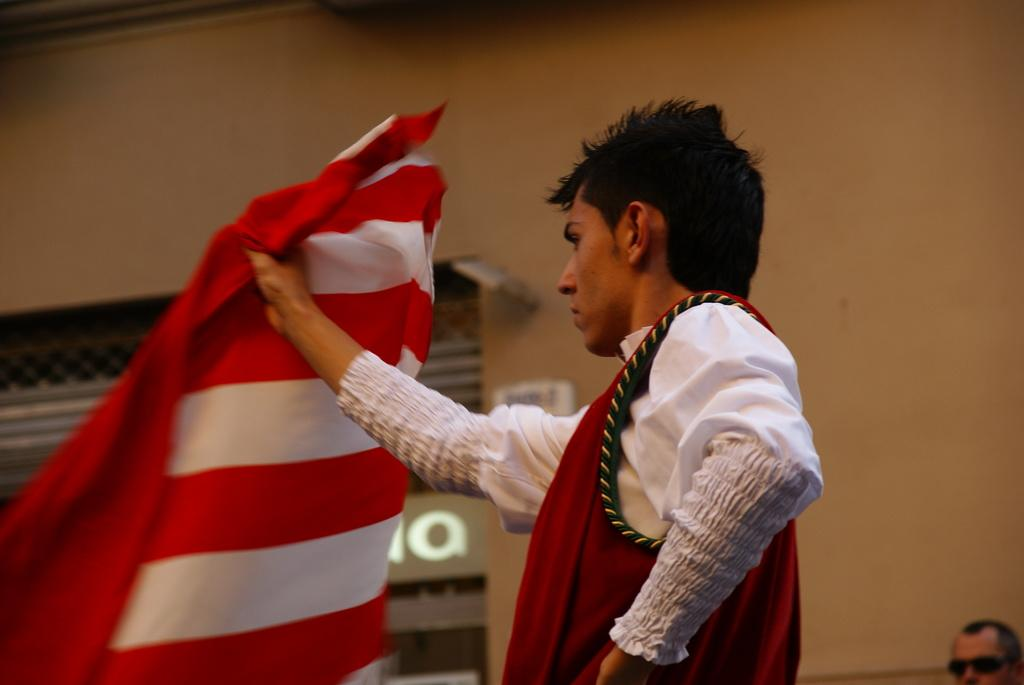How many people are in the image? There are two persons in the image. What is one of the persons holding in his hand? One person is holding a cloth in his hand. What type of zebra can be seen in the image? There is no zebra present in the image. What color is the van in the image? There is no van present in the image. 